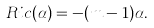<formula> <loc_0><loc_0><loc_500><loc_500>R i c ( \alpha ) = - ( m - 1 ) \alpha .</formula> 